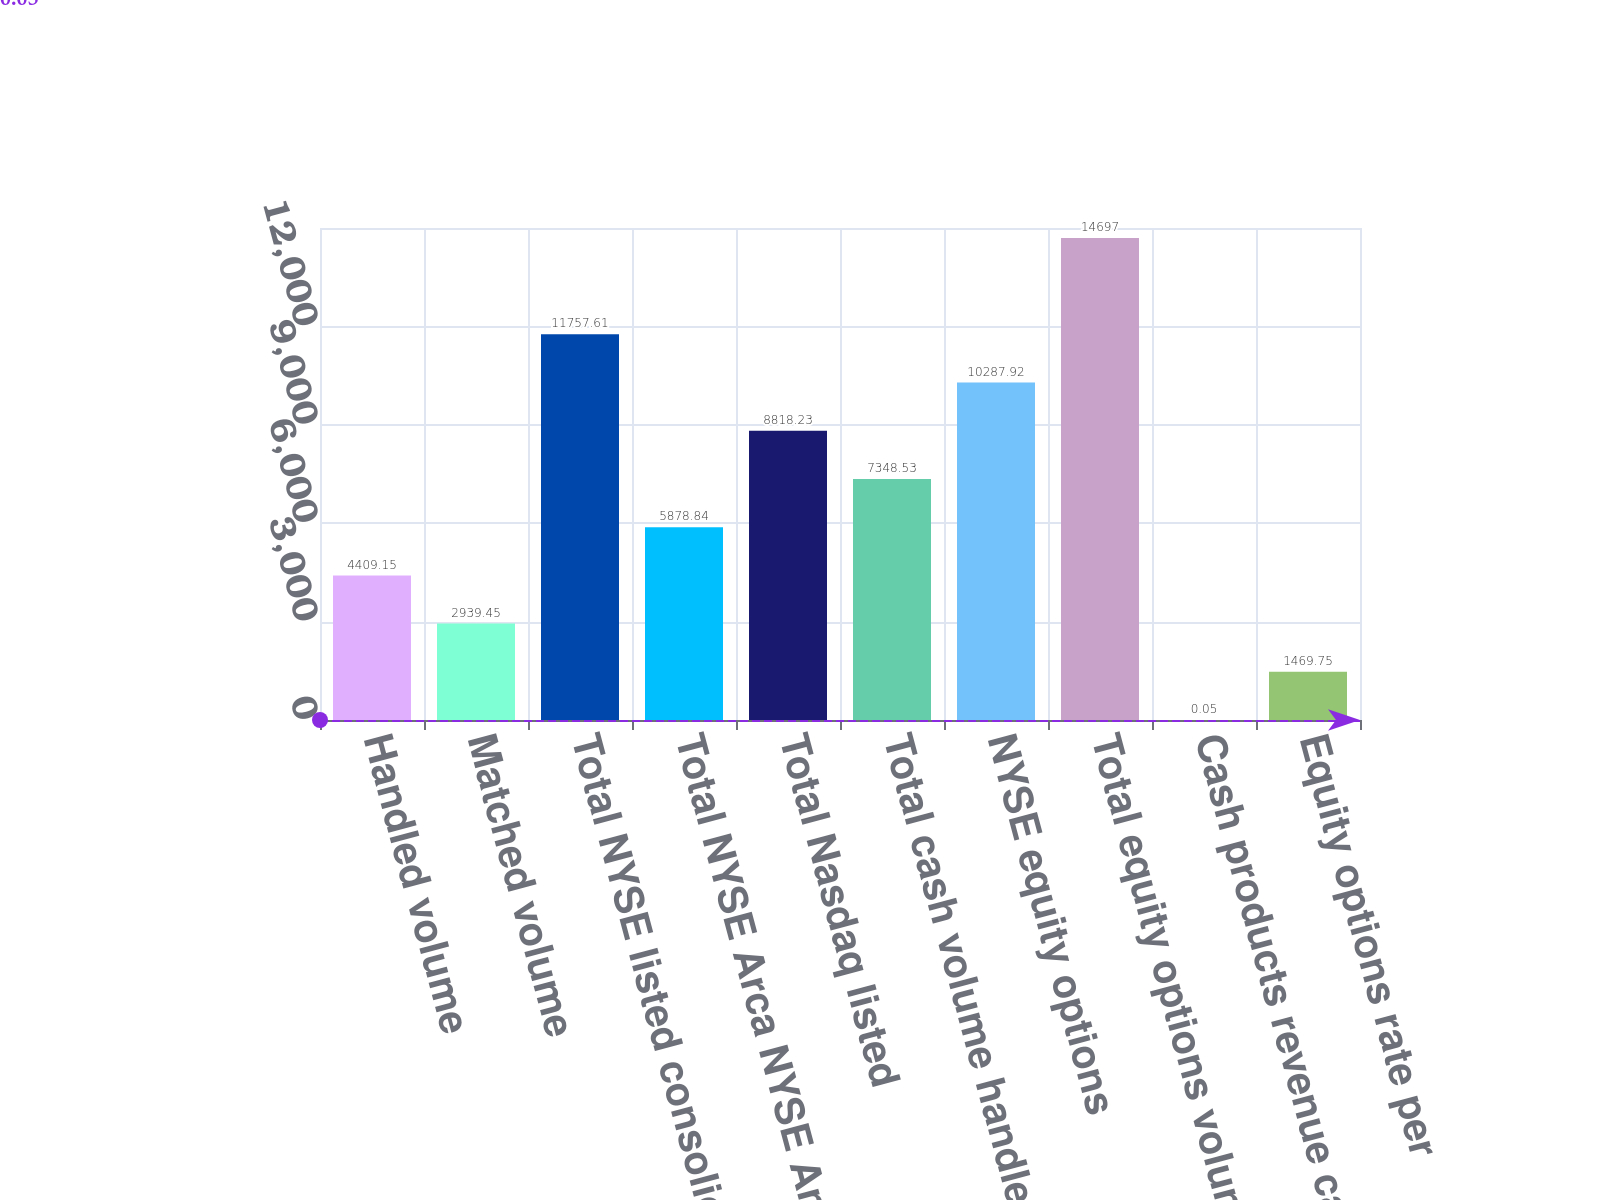Convert chart to OTSL. <chart><loc_0><loc_0><loc_500><loc_500><bar_chart><fcel>Handled volume<fcel>Matched volume<fcel>Total NYSE listed consolidated<fcel>Total NYSE Arca NYSE American<fcel>Total Nasdaq listed<fcel>Total cash volume handled<fcel>NYSE equity options<fcel>Total equity options volume<fcel>Cash products revenue capture<fcel>Equity options rate per<nl><fcel>4409.15<fcel>2939.45<fcel>11757.6<fcel>5878.84<fcel>8818.23<fcel>7348.53<fcel>10287.9<fcel>14697<fcel>0.05<fcel>1469.75<nl></chart> 